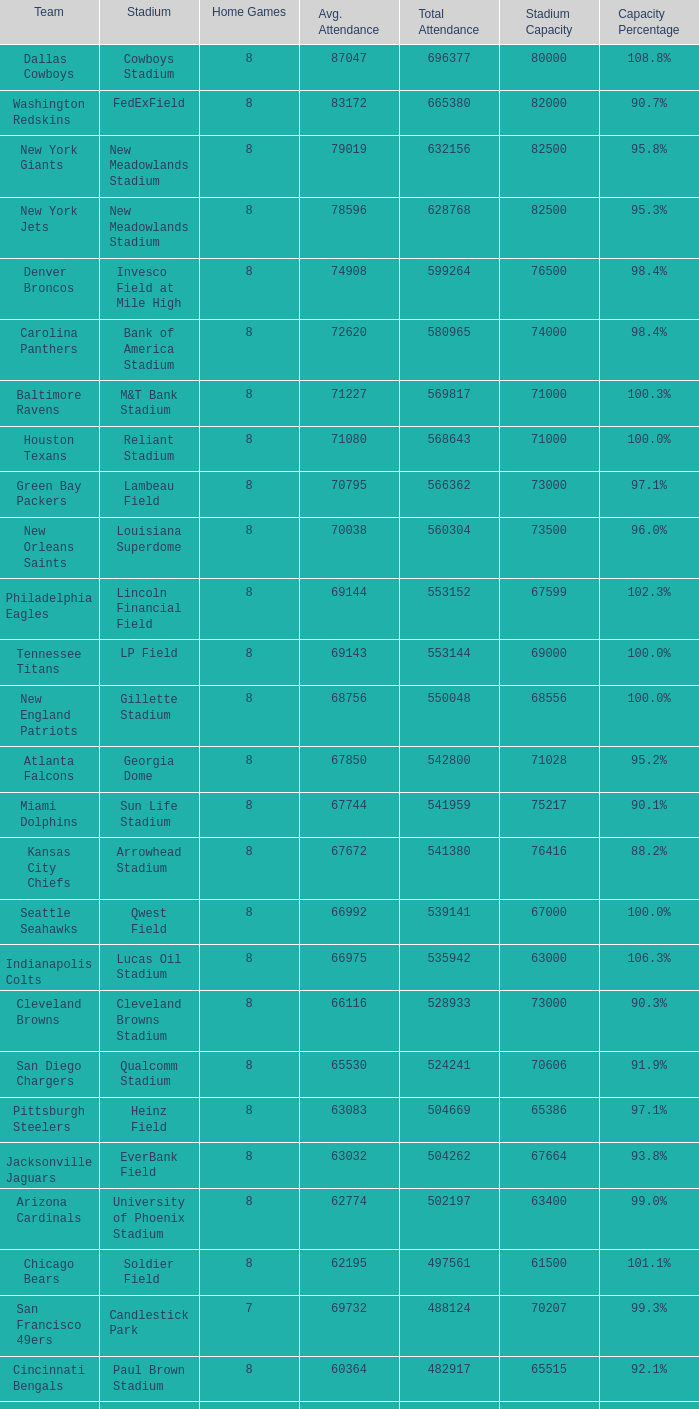What team had a capacity of 102.3%? Philadelphia Eagles. 